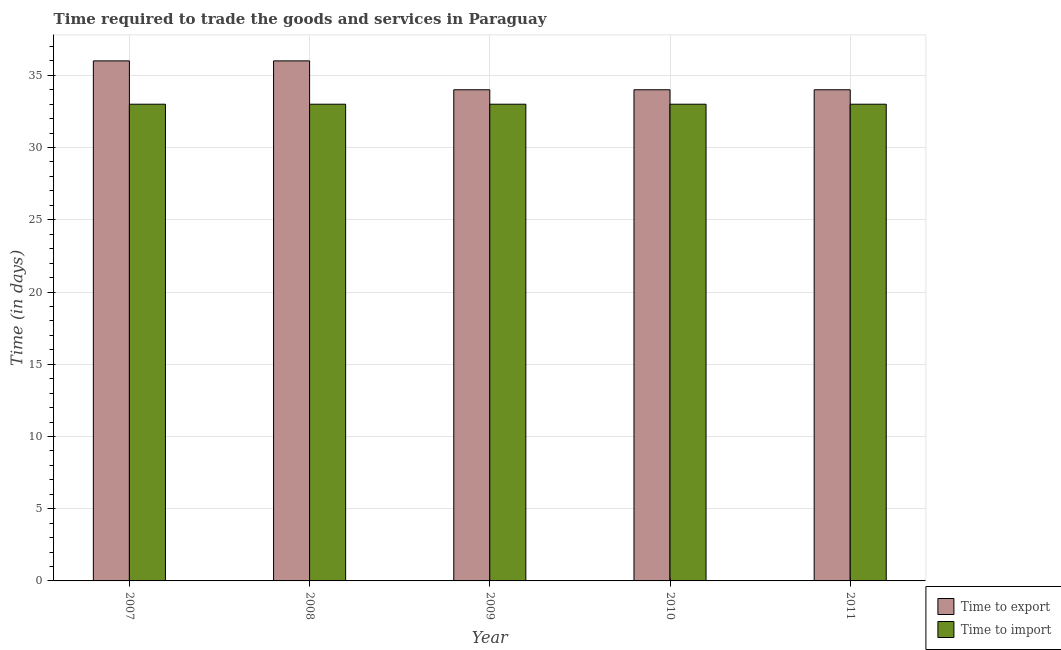How many different coloured bars are there?
Give a very brief answer. 2. How many groups of bars are there?
Provide a succinct answer. 5. Are the number of bars per tick equal to the number of legend labels?
Offer a terse response. Yes. Are the number of bars on each tick of the X-axis equal?
Your answer should be compact. Yes. What is the time to export in 2011?
Offer a terse response. 34. Across all years, what is the maximum time to import?
Provide a succinct answer. 33. Across all years, what is the minimum time to export?
Your answer should be compact. 34. What is the total time to import in the graph?
Offer a terse response. 165. What is the difference between the time to import in 2008 and that in 2010?
Provide a short and direct response. 0. What is the difference between the time to export in 2011 and the time to import in 2007?
Offer a very short reply. -2. In how many years, is the time to import greater than 12 days?
Keep it short and to the point. 5. What is the ratio of the time to import in 2007 to that in 2011?
Your answer should be very brief. 1. What is the difference between the highest and the lowest time to export?
Offer a terse response. 2. What does the 2nd bar from the left in 2011 represents?
Make the answer very short. Time to import. What does the 2nd bar from the right in 2007 represents?
Offer a very short reply. Time to export. How many bars are there?
Offer a terse response. 10. Are all the bars in the graph horizontal?
Your answer should be very brief. No. Does the graph contain grids?
Keep it short and to the point. Yes. How many legend labels are there?
Your answer should be compact. 2. What is the title of the graph?
Provide a succinct answer. Time required to trade the goods and services in Paraguay. What is the label or title of the X-axis?
Your response must be concise. Year. What is the label or title of the Y-axis?
Your response must be concise. Time (in days). What is the Time (in days) of Time to export in 2008?
Provide a short and direct response. 36. What is the Time (in days) in Time to import in 2010?
Keep it short and to the point. 33. Across all years, what is the maximum Time (in days) in Time to import?
Offer a terse response. 33. Across all years, what is the minimum Time (in days) in Time to export?
Your answer should be compact. 34. What is the total Time (in days) of Time to export in the graph?
Give a very brief answer. 174. What is the total Time (in days) in Time to import in the graph?
Your answer should be compact. 165. What is the difference between the Time (in days) in Time to import in 2007 and that in 2008?
Your response must be concise. 0. What is the difference between the Time (in days) in Time to export in 2007 and that in 2009?
Provide a succinct answer. 2. What is the difference between the Time (in days) in Time to import in 2007 and that in 2009?
Give a very brief answer. 0. What is the difference between the Time (in days) of Time to export in 2007 and that in 2010?
Your response must be concise. 2. What is the difference between the Time (in days) in Time to export in 2007 and that in 2011?
Provide a short and direct response. 2. What is the difference between the Time (in days) in Time to import in 2007 and that in 2011?
Provide a succinct answer. 0. What is the difference between the Time (in days) of Time to export in 2008 and that in 2009?
Your answer should be very brief. 2. What is the difference between the Time (in days) of Time to import in 2008 and that in 2009?
Offer a very short reply. 0. What is the difference between the Time (in days) of Time to export in 2009 and that in 2011?
Keep it short and to the point. 0. What is the difference between the Time (in days) of Time to import in 2009 and that in 2011?
Provide a succinct answer. 0. What is the difference between the Time (in days) of Time to import in 2010 and that in 2011?
Your answer should be compact. 0. What is the difference between the Time (in days) of Time to export in 2007 and the Time (in days) of Time to import in 2009?
Ensure brevity in your answer.  3. What is the difference between the Time (in days) of Time to export in 2008 and the Time (in days) of Time to import in 2009?
Your answer should be compact. 3. What is the difference between the Time (in days) in Time to export in 2009 and the Time (in days) in Time to import in 2011?
Offer a terse response. 1. What is the difference between the Time (in days) of Time to export in 2010 and the Time (in days) of Time to import in 2011?
Your response must be concise. 1. What is the average Time (in days) in Time to export per year?
Offer a terse response. 34.8. What is the average Time (in days) of Time to import per year?
Give a very brief answer. 33. In the year 2007, what is the difference between the Time (in days) of Time to export and Time (in days) of Time to import?
Provide a succinct answer. 3. In the year 2008, what is the difference between the Time (in days) in Time to export and Time (in days) in Time to import?
Your answer should be compact. 3. What is the ratio of the Time (in days) of Time to import in 2007 to that in 2008?
Offer a very short reply. 1. What is the ratio of the Time (in days) of Time to export in 2007 to that in 2009?
Give a very brief answer. 1.06. What is the ratio of the Time (in days) of Time to export in 2007 to that in 2010?
Your answer should be very brief. 1.06. What is the ratio of the Time (in days) of Time to import in 2007 to that in 2010?
Make the answer very short. 1. What is the ratio of the Time (in days) in Time to export in 2007 to that in 2011?
Provide a succinct answer. 1.06. What is the ratio of the Time (in days) in Time to import in 2007 to that in 2011?
Keep it short and to the point. 1. What is the ratio of the Time (in days) in Time to export in 2008 to that in 2009?
Your answer should be very brief. 1.06. What is the ratio of the Time (in days) of Time to export in 2008 to that in 2010?
Provide a succinct answer. 1.06. What is the ratio of the Time (in days) of Time to import in 2008 to that in 2010?
Offer a very short reply. 1. What is the ratio of the Time (in days) of Time to export in 2008 to that in 2011?
Offer a very short reply. 1.06. What is the ratio of the Time (in days) of Time to import in 2008 to that in 2011?
Make the answer very short. 1. What is the ratio of the Time (in days) of Time to import in 2009 to that in 2011?
Provide a short and direct response. 1. What is the ratio of the Time (in days) of Time to import in 2010 to that in 2011?
Provide a short and direct response. 1. What is the difference between the highest and the second highest Time (in days) of Time to export?
Your answer should be very brief. 0. What is the difference between the highest and the second highest Time (in days) in Time to import?
Offer a very short reply. 0. What is the difference between the highest and the lowest Time (in days) in Time to export?
Offer a very short reply. 2. What is the difference between the highest and the lowest Time (in days) of Time to import?
Offer a terse response. 0. 